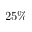Convert formula to latex. <formula><loc_0><loc_0><loc_500><loc_500>2 5 \%</formula> 